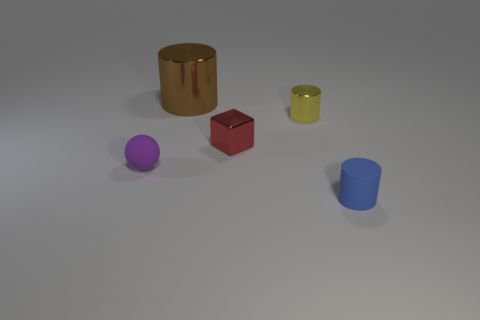Subtract all tiny shiny cylinders. How many cylinders are left? 2 Add 5 red cubes. How many objects exist? 10 Subtract all brown cylinders. How many cylinders are left? 2 Subtract 1 cylinders. How many cylinders are left? 2 Subtract all cyan spheres. How many cyan blocks are left? 0 Subtract all red shiny things. Subtract all tiny shiny cylinders. How many objects are left? 3 Add 3 brown cylinders. How many brown cylinders are left? 4 Add 5 big green metal spheres. How many big green metal spheres exist? 5 Subtract 1 purple spheres. How many objects are left? 4 Subtract all cylinders. How many objects are left? 2 